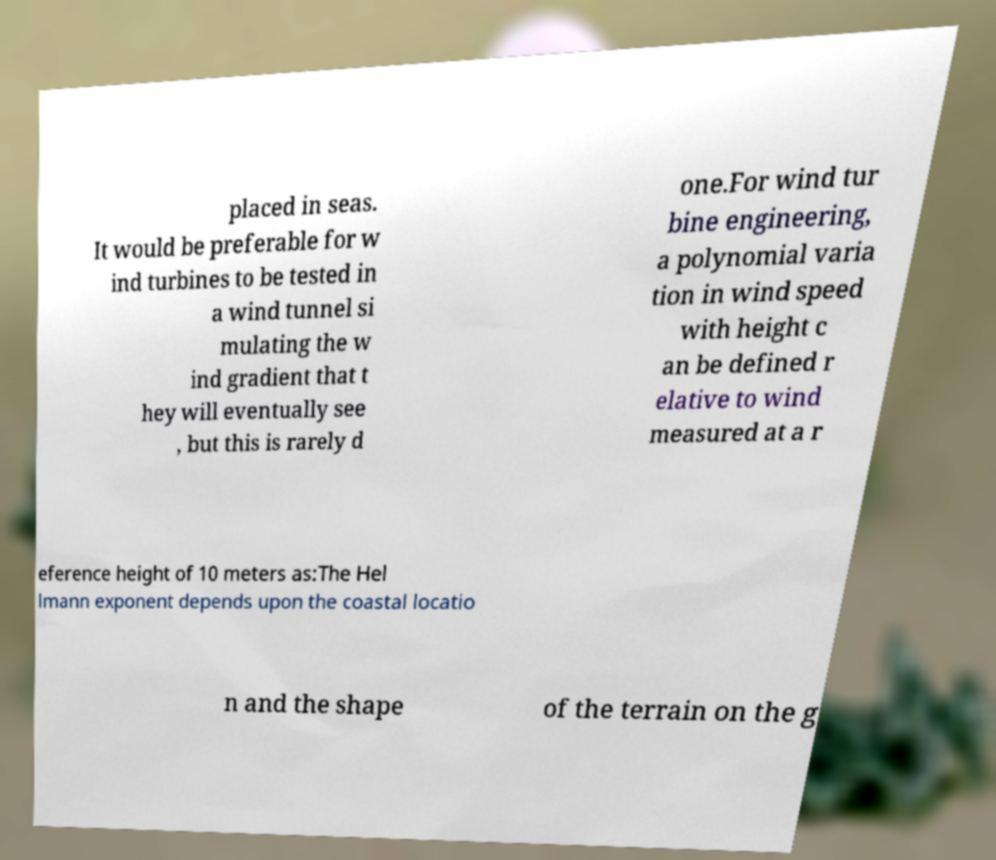I need the written content from this picture converted into text. Can you do that? placed in seas. It would be preferable for w ind turbines to be tested in a wind tunnel si mulating the w ind gradient that t hey will eventually see , but this is rarely d one.For wind tur bine engineering, a polynomial varia tion in wind speed with height c an be defined r elative to wind measured at a r eference height of 10 meters as:The Hel lmann exponent depends upon the coastal locatio n and the shape of the terrain on the g 